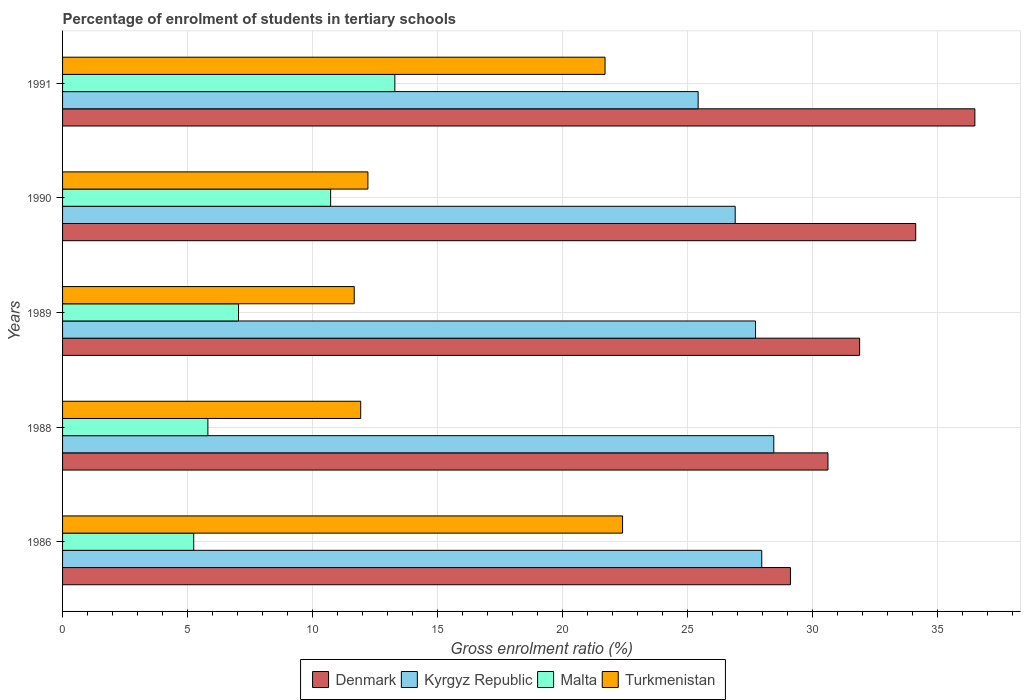How many different coloured bars are there?
Provide a succinct answer. 4. How many groups of bars are there?
Ensure brevity in your answer.  5. How many bars are there on the 4th tick from the bottom?
Offer a terse response. 4. What is the percentage of students enrolled in tertiary schools in Turkmenistan in 1991?
Provide a short and direct response. 21.7. Across all years, what is the maximum percentage of students enrolled in tertiary schools in Denmark?
Keep it short and to the point. 36.49. Across all years, what is the minimum percentage of students enrolled in tertiary schools in Denmark?
Ensure brevity in your answer.  29.11. In which year was the percentage of students enrolled in tertiary schools in Denmark maximum?
Make the answer very short. 1991. What is the total percentage of students enrolled in tertiary schools in Denmark in the graph?
Give a very brief answer. 162.21. What is the difference between the percentage of students enrolled in tertiary schools in Kyrgyz Republic in 1986 and that in 1990?
Keep it short and to the point. 1.06. What is the difference between the percentage of students enrolled in tertiary schools in Denmark in 1991 and the percentage of students enrolled in tertiary schools in Kyrgyz Republic in 1989?
Ensure brevity in your answer.  8.77. What is the average percentage of students enrolled in tertiary schools in Malta per year?
Your answer should be compact. 8.42. In the year 1988, what is the difference between the percentage of students enrolled in tertiary schools in Malta and percentage of students enrolled in tertiary schools in Turkmenistan?
Your response must be concise. -6.11. What is the ratio of the percentage of students enrolled in tertiary schools in Kyrgyz Republic in 1988 to that in 1991?
Keep it short and to the point. 1.12. Is the percentage of students enrolled in tertiary schools in Denmark in 1989 less than that in 1991?
Provide a succinct answer. Yes. Is the difference between the percentage of students enrolled in tertiary schools in Malta in 1988 and 1990 greater than the difference between the percentage of students enrolled in tertiary schools in Turkmenistan in 1988 and 1990?
Your response must be concise. No. What is the difference between the highest and the second highest percentage of students enrolled in tertiary schools in Turkmenistan?
Make the answer very short. 0.7. What is the difference between the highest and the lowest percentage of students enrolled in tertiary schools in Kyrgyz Republic?
Your response must be concise. 3.02. In how many years, is the percentage of students enrolled in tertiary schools in Turkmenistan greater than the average percentage of students enrolled in tertiary schools in Turkmenistan taken over all years?
Provide a short and direct response. 2. What does the 2nd bar from the bottom in 1986 represents?
Provide a short and direct response. Kyrgyz Republic. How many bars are there?
Offer a terse response. 20. Are all the bars in the graph horizontal?
Your response must be concise. Yes. How many years are there in the graph?
Offer a terse response. 5. What is the difference between two consecutive major ticks on the X-axis?
Offer a terse response. 5. Are the values on the major ticks of X-axis written in scientific E-notation?
Provide a short and direct response. No. Does the graph contain grids?
Provide a succinct answer. Yes. What is the title of the graph?
Provide a short and direct response. Percentage of enrolment of students in tertiary schools. What is the Gross enrolment ratio (%) of Denmark in 1986?
Keep it short and to the point. 29.11. What is the Gross enrolment ratio (%) in Kyrgyz Republic in 1986?
Your response must be concise. 27.96. What is the Gross enrolment ratio (%) of Malta in 1986?
Your answer should be very brief. 5.25. What is the Gross enrolment ratio (%) in Turkmenistan in 1986?
Your answer should be very brief. 22.4. What is the Gross enrolment ratio (%) in Denmark in 1988?
Offer a very short reply. 30.61. What is the Gross enrolment ratio (%) in Kyrgyz Republic in 1988?
Provide a short and direct response. 28.45. What is the Gross enrolment ratio (%) in Malta in 1988?
Your answer should be compact. 5.81. What is the Gross enrolment ratio (%) in Turkmenistan in 1988?
Your answer should be very brief. 11.92. What is the Gross enrolment ratio (%) in Denmark in 1989?
Offer a very short reply. 31.88. What is the Gross enrolment ratio (%) of Kyrgyz Republic in 1989?
Offer a very short reply. 27.72. What is the Gross enrolment ratio (%) of Malta in 1989?
Give a very brief answer. 7.04. What is the Gross enrolment ratio (%) of Turkmenistan in 1989?
Your response must be concise. 11.66. What is the Gross enrolment ratio (%) in Denmark in 1990?
Your response must be concise. 34.12. What is the Gross enrolment ratio (%) in Kyrgyz Republic in 1990?
Offer a terse response. 26.9. What is the Gross enrolment ratio (%) in Malta in 1990?
Your answer should be very brief. 10.72. What is the Gross enrolment ratio (%) in Turkmenistan in 1990?
Your response must be concise. 12.21. What is the Gross enrolment ratio (%) in Denmark in 1991?
Provide a short and direct response. 36.49. What is the Gross enrolment ratio (%) of Kyrgyz Republic in 1991?
Make the answer very short. 25.42. What is the Gross enrolment ratio (%) of Malta in 1991?
Provide a short and direct response. 13.29. What is the Gross enrolment ratio (%) of Turkmenistan in 1991?
Make the answer very short. 21.7. Across all years, what is the maximum Gross enrolment ratio (%) of Denmark?
Your answer should be compact. 36.49. Across all years, what is the maximum Gross enrolment ratio (%) of Kyrgyz Republic?
Ensure brevity in your answer.  28.45. Across all years, what is the maximum Gross enrolment ratio (%) in Malta?
Make the answer very short. 13.29. Across all years, what is the maximum Gross enrolment ratio (%) in Turkmenistan?
Provide a short and direct response. 22.4. Across all years, what is the minimum Gross enrolment ratio (%) in Denmark?
Give a very brief answer. 29.11. Across all years, what is the minimum Gross enrolment ratio (%) in Kyrgyz Republic?
Provide a short and direct response. 25.42. Across all years, what is the minimum Gross enrolment ratio (%) in Malta?
Make the answer very short. 5.25. Across all years, what is the minimum Gross enrolment ratio (%) of Turkmenistan?
Offer a terse response. 11.66. What is the total Gross enrolment ratio (%) in Denmark in the graph?
Keep it short and to the point. 162.21. What is the total Gross enrolment ratio (%) of Kyrgyz Republic in the graph?
Ensure brevity in your answer.  136.45. What is the total Gross enrolment ratio (%) of Malta in the graph?
Offer a terse response. 42.11. What is the total Gross enrolment ratio (%) in Turkmenistan in the graph?
Give a very brief answer. 79.89. What is the difference between the Gross enrolment ratio (%) in Denmark in 1986 and that in 1988?
Your response must be concise. -1.5. What is the difference between the Gross enrolment ratio (%) in Kyrgyz Republic in 1986 and that in 1988?
Offer a terse response. -0.48. What is the difference between the Gross enrolment ratio (%) in Malta in 1986 and that in 1988?
Give a very brief answer. -0.57. What is the difference between the Gross enrolment ratio (%) of Turkmenistan in 1986 and that in 1988?
Your response must be concise. 10.47. What is the difference between the Gross enrolment ratio (%) in Denmark in 1986 and that in 1989?
Provide a short and direct response. -2.77. What is the difference between the Gross enrolment ratio (%) in Kyrgyz Republic in 1986 and that in 1989?
Your answer should be compact. 0.25. What is the difference between the Gross enrolment ratio (%) in Malta in 1986 and that in 1989?
Your response must be concise. -1.79. What is the difference between the Gross enrolment ratio (%) of Turkmenistan in 1986 and that in 1989?
Your answer should be compact. 10.73. What is the difference between the Gross enrolment ratio (%) in Denmark in 1986 and that in 1990?
Your answer should be very brief. -5.01. What is the difference between the Gross enrolment ratio (%) in Kyrgyz Republic in 1986 and that in 1990?
Your response must be concise. 1.06. What is the difference between the Gross enrolment ratio (%) in Malta in 1986 and that in 1990?
Offer a very short reply. -5.48. What is the difference between the Gross enrolment ratio (%) of Turkmenistan in 1986 and that in 1990?
Offer a very short reply. 10.19. What is the difference between the Gross enrolment ratio (%) of Denmark in 1986 and that in 1991?
Your answer should be compact. -7.38. What is the difference between the Gross enrolment ratio (%) of Kyrgyz Republic in 1986 and that in 1991?
Offer a terse response. 2.54. What is the difference between the Gross enrolment ratio (%) of Malta in 1986 and that in 1991?
Offer a terse response. -8.04. What is the difference between the Gross enrolment ratio (%) in Turkmenistan in 1986 and that in 1991?
Your response must be concise. 0.7. What is the difference between the Gross enrolment ratio (%) of Denmark in 1988 and that in 1989?
Provide a succinct answer. -1.27. What is the difference between the Gross enrolment ratio (%) of Kyrgyz Republic in 1988 and that in 1989?
Give a very brief answer. 0.73. What is the difference between the Gross enrolment ratio (%) of Malta in 1988 and that in 1989?
Offer a very short reply. -1.22. What is the difference between the Gross enrolment ratio (%) of Turkmenistan in 1988 and that in 1989?
Offer a very short reply. 0.26. What is the difference between the Gross enrolment ratio (%) in Denmark in 1988 and that in 1990?
Provide a short and direct response. -3.51. What is the difference between the Gross enrolment ratio (%) of Kyrgyz Republic in 1988 and that in 1990?
Provide a short and direct response. 1.54. What is the difference between the Gross enrolment ratio (%) of Malta in 1988 and that in 1990?
Keep it short and to the point. -4.91. What is the difference between the Gross enrolment ratio (%) in Turkmenistan in 1988 and that in 1990?
Your answer should be very brief. -0.29. What is the difference between the Gross enrolment ratio (%) in Denmark in 1988 and that in 1991?
Your response must be concise. -5.88. What is the difference between the Gross enrolment ratio (%) of Kyrgyz Republic in 1988 and that in 1991?
Give a very brief answer. 3.02. What is the difference between the Gross enrolment ratio (%) in Malta in 1988 and that in 1991?
Your answer should be compact. -7.48. What is the difference between the Gross enrolment ratio (%) in Turkmenistan in 1988 and that in 1991?
Offer a very short reply. -9.77. What is the difference between the Gross enrolment ratio (%) in Denmark in 1989 and that in 1990?
Offer a terse response. -2.24. What is the difference between the Gross enrolment ratio (%) in Kyrgyz Republic in 1989 and that in 1990?
Make the answer very short. 0.81. What is the difference between the Gross enrolment ratio (%) of Malta in 1989 and that in 1990?
Ensure brevity in your answer.  -3.68. What is the difference between the Gross enrolment ratio (%) of Turkmenistan in 1989 and that in 1990?
Your answer should be very brief. -0.55. What is the difference between the Gross enrolment ratio (%) of Denmark in 1989 and that in 1991?
Your answer should be compact. -4.61. What is the difference between the Gross enrolment ratio (%) of Kyrgyz Republic in 1989 and that in 1991?
Offer a very short reply. 2.29. What is the difference between the Gross enrolment ratio (%) of Malta in 1989 and that in 1991?
Offer a very short reply. -6.25. What is the difference between the Gross enrolment ratio (%) of Turkmenistan in 1989 and that in 1991?
Make the answer very short. -10.03. What is the difference between the Gross enrolment ratio (%) in Denmark in 1990 and that in 1991?
Keep it short and to the point. -2.37. What is the difference between the Gross enrolment ratio (%) in Kyrgyz Republic in 1990 and that in 1991?
Give a very brief answer. 1.48. What is the difference between the Gross enrolment ratio (%) in Malta in 1990 and that in 1991?
Ensure brevity in your answer.  -2.57. What is the difference between the Gross enrolment ratio (%) in Turkmenistan in 1990 and that in 1991?
Make the answer very short. -9.48. What is the difference between the Gross enrolment ratio (%) in Denmark in 1986 and the Gross enrolment ratio (%) in Kyrgyz Republic in 1988?
Give a very brief answer. 0.67. What is the difference between the Gross enrolment ratio (%) in Denmark in 1986 and the Gross enrolment ratio (%) in Malta in 1988?
Offer a terse response. 23.3. What is the difference between the Gross enrolment ratio (%) in Denmark in 1986 and the Gross enrolment ratio (%) in Turkmenistan in 1988?
Offer a very short reply. 17.19. What is the difference between the Gross enrolment ratio (%) of Kyrgyz Republic in 1986 and the Gross enrolment ratio (%) of Malta in 1988?
Give a very brief answer. 22.15. What is the difference between the Gross enrolment ratio (%) of Kyrgyz Republic in 1986 and the Gross enrolment ratio (%) of Turkmenistan in 1988?
Provide a succinct answer. 16.04. What is the difference between the Gross enrolment ratio (%) of Malta in 1986 and the Gross enrolment ratio (%) of Turkmenistan in 1988?
Your response must be concise. -6.68. What is the difference between the Gross enrolment ratio (%) in Denmark in 1986 and the Gross enrolment ratio (%) in Kyrgyz Republic in 1989?
Keep it short and to the point. 1.4. What is the difference between the Gross enrolment ratio (%) of Denmark in 1986 and the Gross enrolment ratio (%) of Malta in 1989?
Give a very brief answer. 22.07. What is the difference between the Gross enrolment ratio (%) of Denmark in 1986 and the Gross enrolment ratio (%) of Turkmenistan in 1989?
Make the answer very short. 17.45. What is the difference between the Gross enrolment ratio (%) of Kyrgyz Republic in 1986 and the Gross enrolment ratio (%) of Malta in 1989?
Keep it short and to the point. 20.93. What is the difference between the Gross enrolment ratio (%) of Kyrgyz Republic in 1986 and the Gross enrolment ratio (%) of Turkmenistan in 1989?
Offer a terse response. 16.3. What is the difference between the Gross enrolment ratio (%) of Malta in 1986 and the Gross enrolment ratio (%) of Turkmenistan in 1989?
Your answer should be very brief. -6.42. What is the difference between the Gross enrolment ratio (%) of Denmark in 1986 and the Gross enrolment ratio (%) of Kyrgyz Republic in 1990?
Provide a short and direct response. 2.21. What is the difference between the Gross enrolment ratio (%) of Denmark in 1986 and the Gross enrolment ratio (%) of Malta in 1990?
Your answer should be compact. 18.39. What is the difference between the Gross enrolment ratio (%) in Denmark in 1986 and the Gross enrolment ratio (%) in Turkmenistan in 1990?
Your answer should be very brief. 16.9. What is the difference between the Gross enrolment ratio (%) in Kyrgyz Republic in 1986 and the Gross enrolment ratio (%) in Malta in 1990?
Ensure brevity in your answer.  17.24. What is the difference between the Gross enrolment ratio (%) in Kyrgyz Republic in 1986 and the Gross enrolment ratio (%) in Turkmenistan in 1990?
Your answer should be very brief. 15.75. What is the difference between the Gross enrolment ratio (%) in Malta in 1986 and the Gross enrolment ratio (%) in Turkmenistan in 1990?
Your answer should be compact. -6.97. What is the difference between the Gross enrolment ratio (%) of Denmark in 1986 and the Gross enrolment ratio (%) of Kyrgyz Republic in 1991?
Your answer should be very brief. 3.69. What is the difference between the Gross enrolment ratio (%) of Denmark in 1986 and the Gross enrolment ratio (%) of Malta in 1991?
Make the answer very short. 15.82. What is the difference between the Gross enrolment ratio (%) of Denmark in 1986 and the Gross enrolment ratio (%) of Turkmenistan in 1991?
Ensure brevity in your answer.  7.42. What is the difference between the Gross enrolment ratio (%) in Kyrgyz Republic in 1986 and the Gross enrolment ratio (%) in Malta in 1991?
Offer a terse response. 14.67. What is the difference between the Gross enrolment ratio (%) in Kyrgyz Republic in 1986 and the Gross enrolment ratio (%) in Turkmenistan in 1991?
Give a very brief answer. 6.27. What is the difference between the Gross enrolment ratio (%) in Malta in 1986 and the Gross enrolment ratio (%) in Turkmenistan in 1991?
Keep it short and to the point. -16.45. What is the difference between the Gross enrolment ratio (%) in Denmark in 1988 and the Gross enrolment ratio (%) in Kyrgyz Republic in 1989?
Give a very brief answer. 2.9. What is the difference between the Gross enrolment ratio (%) in Denmark in 1988 and the Gross enrolment ratio (%) in Malta in 1989?
Provide a succinct answer. 23.58. What is the difference between the Gross enrolment ratio (%) in Denmark in 1988 and the Gross enrolment ratio (%) in Turkmenistan in 1989?
Ensure brevity in your answer.  18.95. What is the difference between the Gross enrolment ratio (%) of Kyrgyz Republic in 1988 and the Gross enrolment ratio (%) of Malta in 1989?
Ensure brevity in your answer.  21.41. What is the difference between the Gross enrolment ratio (%) of Kyrgyz Republic in 1988 and the Gross enrolment ratio (%) of Turkmenistan in 1989?
Offer a terse response. 16.78. What is the difference between the Gross enrolment ratio (%) in Malta in 1988 and the Gross enrolment ratio (%) in Turkmenistan in 1989?
Make the answer very short. -5.85. What is the difference between the Gross enrolment ratio (%) in Denmark in 1988 and the Gross enrolment ratio (%) in Kyrgyz Republic in 1990?
Make the answer very short. 3.71. What is the difference between the Gross enrolment ratio (%) of Denmark in 1988 and the Gross enrolment ratio (%) of Malta in 1990?
Make the answer very short. 19.89. What is the difference between the Gross enrolment ratio (%) of Denmark in 1988 and the Gross enrolment ratio (%) of Turkmenistan in 1990?
Your answer should be very brief. 18.4. What is the difference between the Gross enrolment ratio (%) of Kyrgyz Republic in 1988 and the Gross enrolment ratio (%) of Malta in 1990?
Your response must be concise. 17.72. What is the difference between the Gross enrolment ratio (%) of Kyrgyz Republic in 1988 and the Gross enrolment ratio (%) of Turkmenistan in 1990?
Provide a short and direct response. 16.23. What is the difference between the Gross enrolment ratio (%) of Malta in 1988 and the Gross enrolment ratio (%) of Turkmenistan in 1990?
Make the answer very short. -6.4. What is the difference between the Gross enrolment ratio (%) of Denmark in 1988 and the Gross enrolment ratio (%) of Kyrgyz Republic in 1991?
Your answer should be very brief. 5.19. What is the difference between the Gross enrolment ratio (%) of Denmark in 1988 and the Gross enrolment ratio (%) of Malta in 1991?
Provide a short and direct response. 17.32. What is the difference between the Gross enrolment ratio (%) in Denmark in 1988 and the Gross enrolment ratio (%) in Turkmenistan in 1991?
Offer a terse response. 8.92. What is the difference between the Gross enrolment ratio (%) of Kyrgyz Republic in 1988 and the Gross enrolment ratio (%) of Malta in 1991?
Your answer should be compact. 15.16. What is the difference between the Gross enrolment ratio (%) of Kyrgyz Republic in 1988 and the Gross enrolment ratio (%) of Turkmenistan in 1991?
Offer a very short reply. 6.75. What is the difference between the Gross enrolment ratio (%) in Malta in 1988 and the Gross enrolment ratio (%) in Turkmenistan in 1991?
Provide a short and direct response. -15.88. What is the difference between the Gross enrolment ratio (%) in Denmark in 1989 and the Gross enrolment ratio (%) in Kyrgyz Republic in 1990?
Give a very brief answer. 4.98. What is the difference between the Gross enrolment ratio (%) in Denmark in 1989 and the Gross enrolment ratio (%) in Malta in 1990?
Keep it short and to the point. 21.16. What is the difference between the Gross enrolment ratio (%) in Denmark in 1989 and the Gross enrolment ratio (%) in Turkmenistan in 1990?
Provide a short and direct response. 19.67. What is the difference between the Gross enrolment ratio (%) of Kyrgyz Republic in 1989 and the Gross enrolment ratio (%) of Malta in 1990?
Offer a very short reply. 16.99. What is the difference between the Gross enrolment ratio (%) of Kyrgyz Republic in 1989 and the Gross enrolment ratio (%) of Turkmenistan in 1990?
Keep it short and to the point. 15.5. What is the difference between the Gross enrolment ratio (%) of Malta in 1989 and the Gross enrolment ratio (%) of Turkmenistan in 1990?
Give a very brief answer. -5.18. What is the difference between the Gross enrolment ratio (%) in Denmark in 1989 and the Gross enrolment ratio (%) in Kyrgyz Republic in 1991?
Provide a short and direct response. 6.46. What is the difference between the Gross enrolment ratio (%) of Denmark in 1989 and the Gross enrolment ratio (%) of Malta in 1991?
Ensure brevity in your answer.  18.59. What is the difference between the Gross enrolment ratio (%) in Denmark in 1989 and the Gross enrolment ratio (%) in Turkmenistan in 1991?
Ensure brevity in your answer.  10.18. What is the difference between the Gross enrolment ratio (%) in Kyrgyz Republic in 1989 and the Gross enrolment ratio (%) in Malta in 1991?
Provide a short and direct response. 14.43. What is the difference between the Gross enrolment ratio (%) of Kyrgyz Republic in 1989 and the Gross enrolment ratio (%) of Turkmenistan in 1991?
Offer a terse response. 6.02. What is the difference between the Gross enrolment ratio (%) in Malta in 1989 and the Gross enrolment ratio (%) in Turkmenistan in 1991?
Give a very brief answer. -14.66. What is the difference between the Gross enrolment ratio (%) of Denmark in 1990 and the Gross enrolment ratio (%) of Kyrgyz Republic in 1991?
Offer a very short reply. 8.7. What is the difference between the Gross enrolment ratio (%) of Denmark in 1990 and the Gross enrolment ratio (%) of Malta in 1991?
Offer a very short reply. 20.83. What is the difference between the Gross enrolment ratio (%) in Denmark in 1990 and the Gross enrolment ratio (%) in Turkmenistan in 1991?
Make the answer very short. 12.43. What is the difference between the Gross enrolment ratio (%) of Kyrgyz Republic in 1990 and the Gross enrolment ratio (%) of Malta in 1991?
Make the answer very short. 13.61. What is the difference between the Gross enrolment ratio (%) of Kyrgyz Republic in 1990 and the Gross enrolment ratio (%) of Turkmenistan in 1991?
Offer a very short reply. 5.21. What is the difference between the Gross enrolment ratio (%) of Malta in 1990 and the Gross enrolment ratio (%) of Turkmenistan in 1991?
Offer a terse response. -10.98. What is the average Gross enrolment ratio (%) of Denmark per year?
Provide a succinct answer. 32.44. What is the average Gross enrolment ratio (%) in Kyrgyz Republic per year?
Keep it short and to the point. 27.29. What is the average Gross enrolment ratio (%) of Malta per year?
Make the answer very short. 8.42. What is the average Gross enrolment ratio (%) of Turkmenistan per year?
Ensure brevity in your answer.  15.98. In the year 1986, what is the difference between the Gross enrolment ratio (%) of Denmark and Gross enrolment ratio (%) of Kyrgyz Republic?
Provide a short and direct response. 1.15. In the year 1986, what is the difference between the Gross enrolment ratio (%) of Denmark and Gross enrolment ratio (%) of Malta?
Provide a succinct answer. 23.87. In the year 1986, what is the difference between the Gross enrolment ratio (%) in Denmark and Gross enrolment ratio (%) in Turkmenistan?
Offer a terse response. 6.71. In the year 1986, what is the difference between the Gross enrolment ratio (%) in Kyrgyz Republic and Gross enrolment ratio (%) in Malta?
Your answer should be very brief. 22.72. In the year 1986, what is the difference between the Gross enrolment ratio (%) in Kyrgyz Republic and Gross enrolment ratio (%) in Turkmenistan?
Offer a very short reply. 5.57. In the year 1986, what is the difference between the Gross enrolment ratio (%) in Malta and Gross enrolment ratio (%) in Turkmenistan?
Provide a succinct answer. -17.15. In the year 1988, what is the difference between the Gross enrolment ratio (%) of Denmark and Gross enrolment ratio (%) of Kyrgyz Republic?
Provide a short and direct response. 2.17. In the year 1988, what is the difference between the Gross enrolment ratio (%) of Denmark and Gross enrolment ratio (%) of Malta?
Your answer should be compact. 24.8. In the year 1988, what is the difference between the Gross enrolment ratio (%) of Denmark and Gross enrolment ratio (%) of Turkmenistan?
Your answer should be very brief. 18.69. In the year 1988, what is the difference between the Gross enrolment ratio (%) of Kyrgyz Republic and Gross enrolment ratio (%) of Malta?
Keep it short and to the point. 22.63. In the year 1988, what is the difference between the Gross enrolment ratio (%) of Kyrgyz Republic and Gross enrolment ratio (%) of Turkmenistan?
Your answer should be compact. 16.52. In the year 1988, what is the difference between the Gross enrolment ratio (%) in Malta and Gross enrolment ratio (%) in Turkmenistan?
Your answer should be compact. -6.11. In the year 1989, what is the difference between the Gross enrolment ratio (%) of Denmark and Gross enrolment ratio (%) of Kyrgyz Republic?
Provide a short and direct response. 4.16. In the year 1989, what is the difference between the Gross enrolment ratio (%) in Denmark and Gross enrolment ratio (%) in Malta?
Make the answer very short. 24.84. In the year 1989, what is the difference between the Gross enrolment ratio (%) in Denmark and Gross enrolment ratio (%) in Turkmenistan?
Your response must be concise. 20.21. In the year 1989, what is the difference between the Gross enrolment ratio (%) of Kyrgyz Republic and Gross enrolment ratio (%) of Malta?
Your answer should be compact. 20.68. In the year 1989, what is the difference between the Gross enrolment ratio (%) in Kyrgyz Republic and Gross enrolment ratio (%) in Turkmenistan?
Your answer should be compact. 16.05. In the year 1989, what is the difference between the Gross enrolment ratio (%) in Malta and Gross enrolment ratio (%) in Turkmenistan?
Ensure brevity in your answer.  -4.63. In the year 1990, what is the difference between the Gross enrolment ratio (%) of Denmark and Gross enrolment ratio (%) of Kyrgyz Republic?
Provide a short and direct response. 7.22. In the year 1990, what is the difference between the Gross enrolment ratio (%) of Denmark and Gross enrolment ratio (%) of Malta?
Give a very brief answer. 23.4. In the year 1990, what is the difference between the Gross enrolment ratio (%) of Denmark and Gross enrolment ratio (%) of Turkmenistan?
Offer a very short reply. 21.91. In the year 1990, what is the difference between the Gross enrolment ratio (%) of Kyrgyz Republic and Gross enrolment ratio (%) of Malta?
Make the answer very short. 16.18. In the year 1990, what is the difference between the Gross enrolment ratio (%) of Kyrgyz Republic and Gross enrolment ratio (%) of Turkmenistan?
Offer a terse response. 14.69. In the year 1990, what is the difference between the Gross enrolment ratio (%) of Malta and Gross enrolment ratio (%) of Turkmenistan?
Offer a very short reply. -1.49. In the year 1991, what is the difference between the Gross enrolment ratio (%) in Denmark and Gross enrolment ratio (%) in Kyrgyz Republic?
Provide a succinct answer. 11.07. In the year 1991, what is the difference between the Gross enrolment ratio (%) in Denmark and Gross enrolment ratio (%) in Malta?
Keep it short and to the point. 23.2. In the year 1991, what is the difference between the Gross enrolment ratio (%) in Denmark and Gross enrolment ratio (%) in Turkmenistan?
Provide a succinct answer. 14.79. In the year 1991, what is the difference between the Gross enrolment ratio (%) of Kyrgyz Republic and Gross enrolment ratio (%) of Malta?
Offer a terse response. 12.13. In the year 1991, what is the difference between the Gross enrolment ratio (%) in Kyrgyz Republic and Gross enrolment ratio (%) in Turkmenistan?
Ensure brevity in your answer.  3.72. In the year 1991, what is the difference between the Gross enrolment ratio (%) of Malta and Gross enrolment ratio (%) of Turkmenistan?
Make the answer very short. -8.41. What is the ratio of the Gross enrolment ratio (%) of Denmark in 1986 to that in 1988?
Provide a short and direct response. 0.95. What is the ratio of the Gross enrolment ratio (%) in Kyrgyz Republic in 1986 to that in 1988?
Your answer should be very brief. 0.98. What is the ratio of the Gross enrolment ratio (%) in Malta in 1986 to that in 1988?
Give a very brief answer. 0.9. What is the ratio of the Gross enrolment ratio (%) in Turkmenistan in 1986 to that in 1988?
Your response must be concise. 1.88. What is the ratio of the Gross enrolment ratio (%) of Denmark in 1986 to that in 1989?
Offer a terse response. 0.91. What is the ratio of the Gross enrolment ratio (%) in Malta in 1986 to that in 1989?
Give a very brief answer. 0.75. What is the ratio of the Gross enrolment ratio (%) of Turkmenistan in 1986 to that in 1989?
Provide a succinct answer. 1.92. What is the ratio of the Gross enrolment ratio (%) in Denmark in 1986 to that in 1990?
Your answer should be compact. 0.85. What is the ratio of the Gross enrolment ratio (%) in Kyrgyz Republic in 1986 to that in 1990?
Provide a short and direct response. 1.04. What is the ratio of the Gross enrolment ratio (%) in Malta in 1986 to that in 1990?
Offer a terse response. 0.49. What is the ratio of the Gross enrolment ratio (%) in Turkmenistan in 1986 to that in 1990?
Make the answer very short. 1.83. What is the ratio of the Gross enrolment ratio (%) in Denmark in 1986 to that in 1991?
Make the answer very short. 0.8. What is the ratio of the Gross enrolment ratio (%) in Kyrgyz Republic in 1986 to that in 1991?
Keep it short and to the point. 1.1. What is the ratio of the Gross enrolment ratio (%) of Malta in 1986 to that in 1991?
Ensure brevity in your answer.  0.39. What is the ratio of the Gross enrolment ratio (%) in Turkmenistan in 1986 to that in 1991?
Give a very brief answer. 1.03. What is the ratio of the Gross enrolment ratio (%) of Denmark in 1988 to that in 1989?
Ensure brevity in your answer.  0.96. What is the ratio of the Gross enrolment ratio (%) of Kyrgyz Republic in 1988 to that in 1989?
Ensure brevity in your answer.  1.03. What is the ratio of the Gross enrolment ratio (%) in Malta in 1988 to that in 1989?
Your response must be concise. 0.83. What is the ratio of the Gross enrolment ratio (%) of Turkmenistan in 1988 to that in 1989?
Keep it short and to the point. 1.02. What is the ratio of the Gross enrolment ratio (%) of Denmark in 1988 to that in 1990?
Give a very brief answer. 0.9. What is the ratio of the Gross enrolment ratio (%) of Kyrgyz Republic in 1988 to that in 1990?
Your response must be concise. 1.06. What is the ratio of the Gross enrolment ratio (%) in Malta in 1988 to that in 1990?
Keep it short and to the point. 0.54. What is the ratio of the Gross enrolment ratio (%) in Turkmenistan in 1988 to that in 1990?
Your answer should be compact. 0.98. What is the ratio of the Gross enrolment ratio (%) in Denmark in 1988 to that in 1991?
Offer a very short reply. 0.84. What is the ratio of the Gross enrolment ratio (%) in Kyrgyz Republic in 1988 to that in 1991?
Provide a succinct answer. 1.12. What is the ratio of the Gross enrolment ratio (%) of Malta in 1988 to that in 1991?
Your answer should be compact. 0.44. What is the ratio of the Gross enrolment ratio (%) in Turkmenistan in 1988 to that in 1991?
Provide a succinct answer. 0.55. What is the ratio of the Gross enrolment ratio (%) of Denmark in 1989 to that in 1990?
Offer a very short reply. 0.93. What is the ratio of the Gross enrolment ratio (%) in Kyrgyz Republic in 1989 to that in 1990?
Provide a short and direct response. 1.03. What is the ratio of the Gross enrolment ratio (%) of Malta in 1989 to that in 1990?
Keep it short and to the point. 0.66. What is the ratio of the Gross enrolment ratio (%) of Turkmenistan in 1989 to that in 1990?
Offer a terse response. 0.96. What is the ratio of the Gross enrolment ratio (%) of Denmark in 1989 to that in 1991?
Provide a succinct answer. 0.87. What is the ratio of the Gross enrolment ratio (%) of Kyrgyz Republic in 1989 to that in 1991?
Offer a very short reply. 1.09. What is the ratio of the Gross enrolment ratio (%) in Malta in 1989 to that in 1991?
Offer a terse response. 0.53. What is the ratio of the Gross enrolment ratio (%) of Turkmenistan in 1989 to that in 1991?
Provide a short and direct response. 0.54. What is the ratio of the Gross enrolment ratio (%) of Denmark in 1990 to that in 1991?
Offer a very short reply. 0.94. What is the ratio of the Gross enrolment ratio (%) in Kyrgyz Republic in 1990 to that in 1991?
Your answer should be compact. 1.06. What is the ratio of the Gross enrolment ratio (%) of Malta in 1990 to that in 1991?
Make the answer very short. 0.81. What is the ratio of the Gross enrolment ratio (%) in Turkmenistan in 1990 to that in 1991?
Your answer should be compact. 0.56. What is the difference between the highest and the second highest Gross enrolment ratio (%) in Denmark?
Make the answer very short. 2.37. What is the difference between the highest and the second highest Gross enrolment ratio (%) in Kyrgyz Republic?
Keep it short and to the point. 0.48. What is the difference between the highest and the second highest Gross enrolment ratio (%) in Malta?
Your answer should be very brief. 2.57. What is the difference between the highest and the second highest Gross enrolment ratio (%) of Turkmenistan?
Make the answer very short. 0.7. What is the difference between the highest and the lowest Gross enrolment ratio (%) in Denmark?
Provide a succinct answer. 7.38. What is the difference between the highest and the lowest Gross enrolment ratio (%) of Kyrgyz Republic?
Your response must be concise. 3.02. What is the difference between the highest and the lowest Gross enrolment ratio (%) of Malta?
Ensure brevity in your answer.  8.04. What is the difference between the highest and the lowest Gross enrolment ratio (%) in Turkmenistan?
Give a very brief answer. 10.73. 